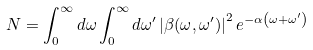<formula> <loc_0><loc_0><loc_500><loc_500>N = \int _ { 0 } ^ { \infty } d \omega \int _ { 0 } ^ { \infty } d \omega ^ { \prime } \left | \beta ( \omega , \omega ^ { \prime } ) \right | ^ { 2 } e ^ { - \alpha \left ( \omega + \omega ^ { \prime } \right ) }</formula> 